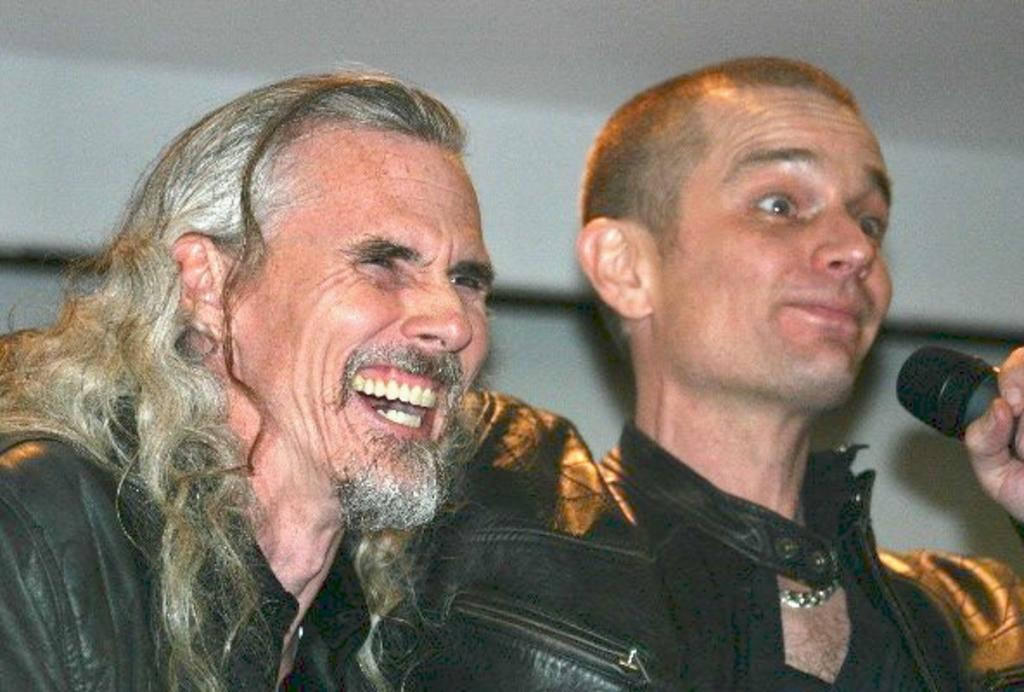What are the people in the image doing? There are men standing in the image. What are the men wearing? The men are wearing black color jackets. Can you describe the man holding an object in his hand? Yes, there is a man holding a mic in his hand. Where is the dock located in the image? There is no dock present in the image. What type of book is the man reading in the image? There is no book present in the image. 